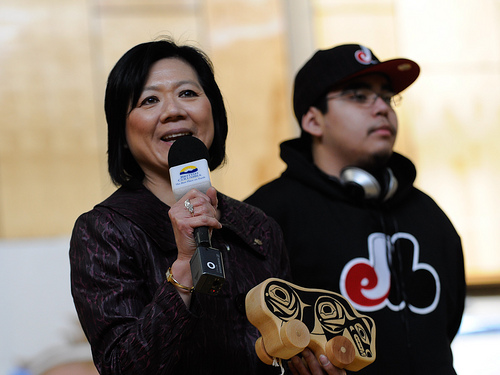<image>
Can you confirm if the lady is under the mike? No. The lady is not positioned under the mike. The vertical relationship between these objects is different. 